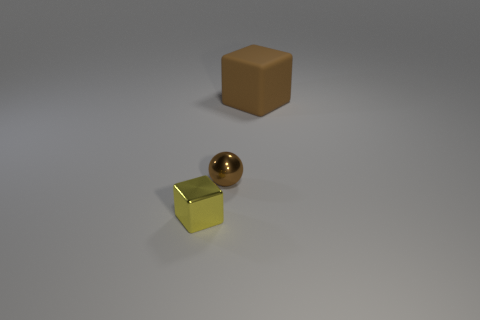Subtract all brown cubes. How many cubes are left? 1 Subtract all balls. How many objects are left? 2 Add 3 tiny purple blocks. How many objects exist? 6 Add 1 tiny gray metallic things. How many tiny gray metallic things exist? 1 Subtract 0 blue blocks. How many objects are left? 3 Subtract all blue spheres. Subtract all red blocks. How many spheres are left? 1 Subtract all large blue matte cubes. Subtract all blocks. How many objects are left? 1 Add 2 brown metallic objects. How many brown metallic objects are left? 3 